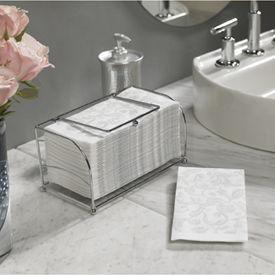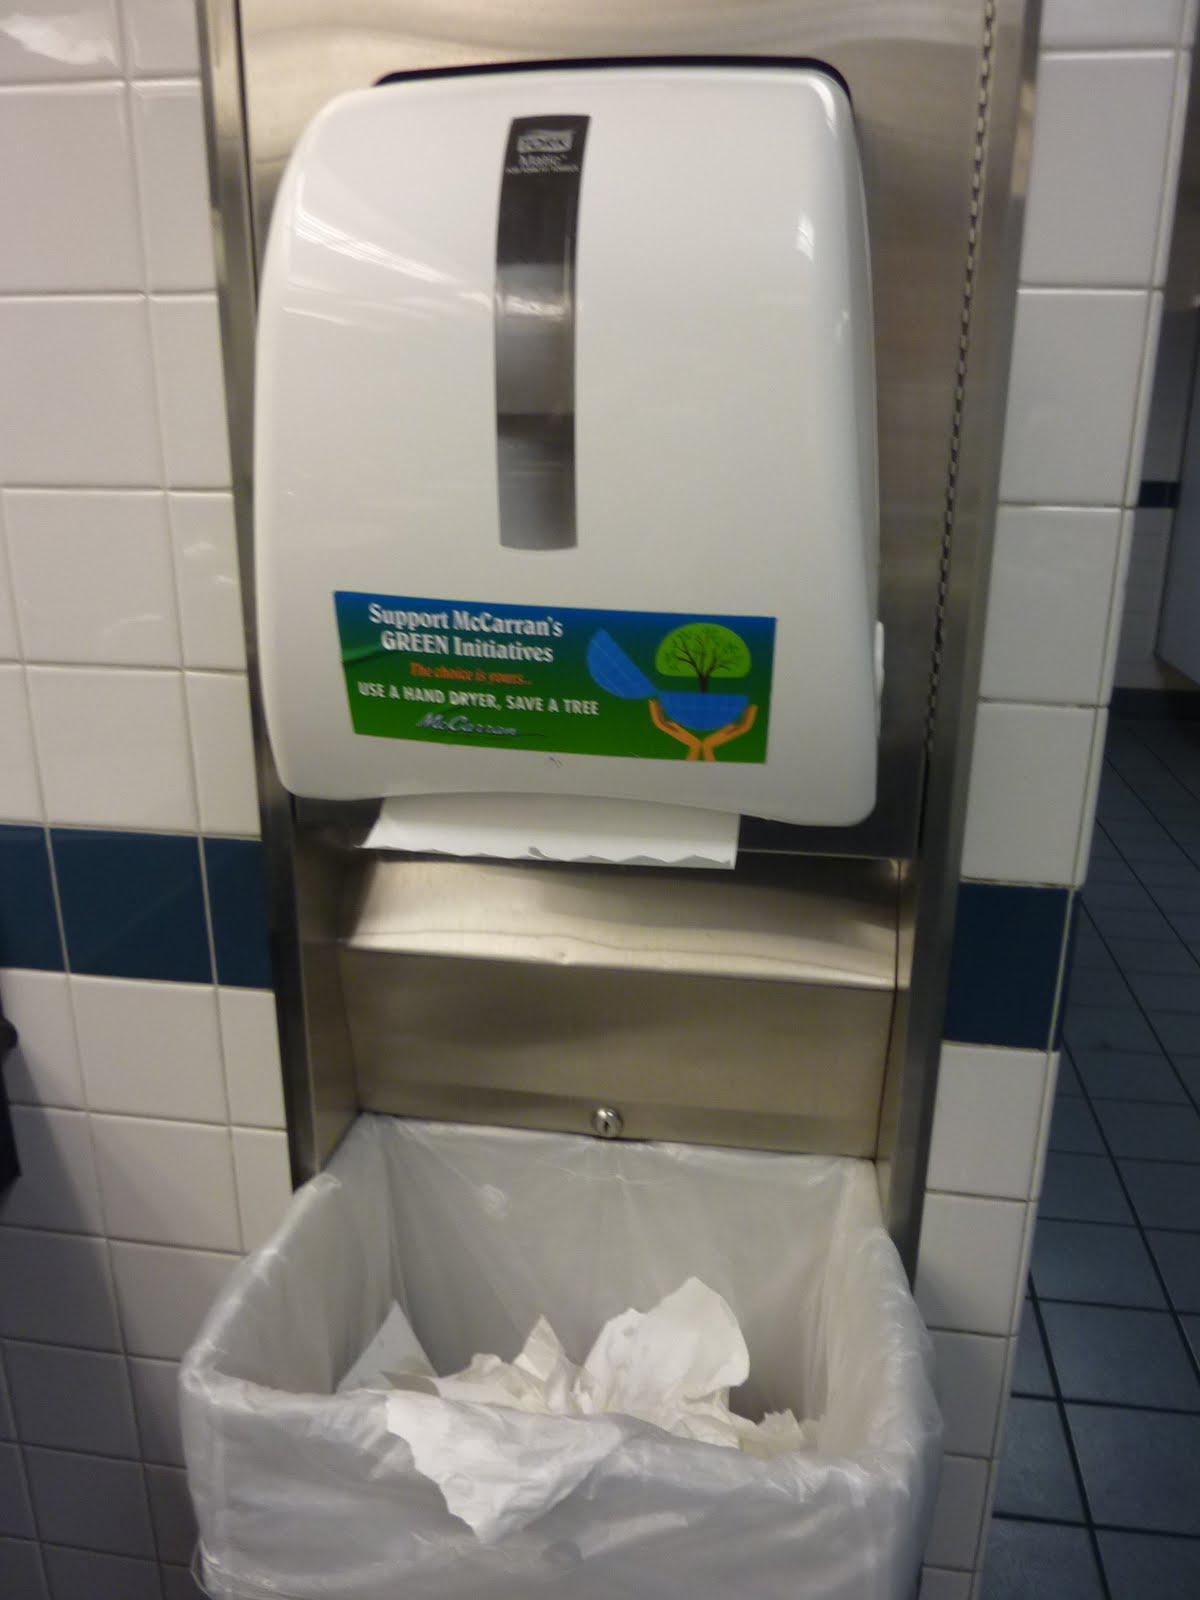The first image is the image on the left, the second image is the image on the right. Examine the images to the left and right. Is the description "In one image, a roll of white paper towels in on a chrome rack attached to the inside of a white cabinet door." accurate? Answer yes or no. No. The first image is the image on the left, the second image is the image on the right. For the images displayed, is the sentence "An image shows one white towel roll mounted on a bar hung on a cabinet door." factually correct? Answer yes or no. No. 